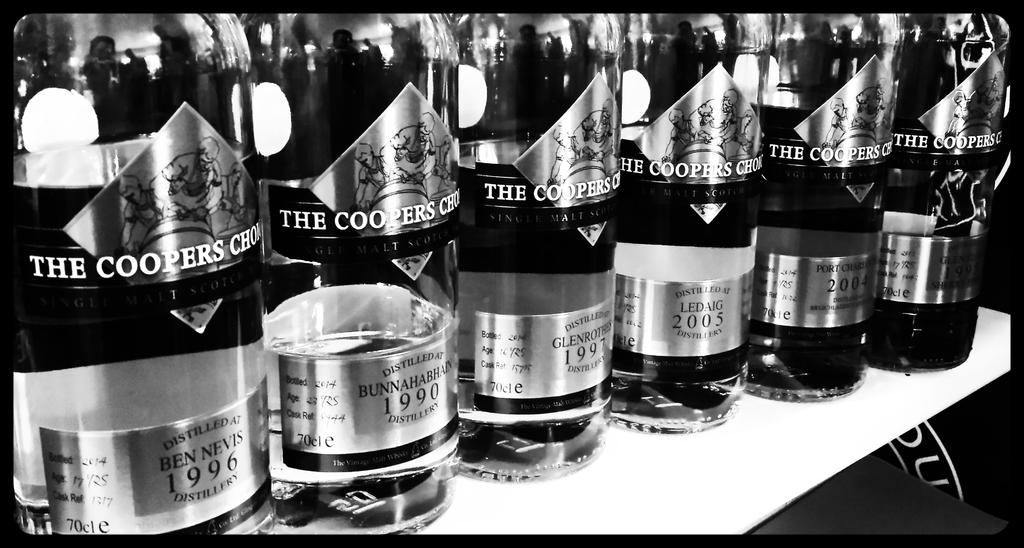<image>
Provide a brief description of the given image. the name coopers that is on a bottle 